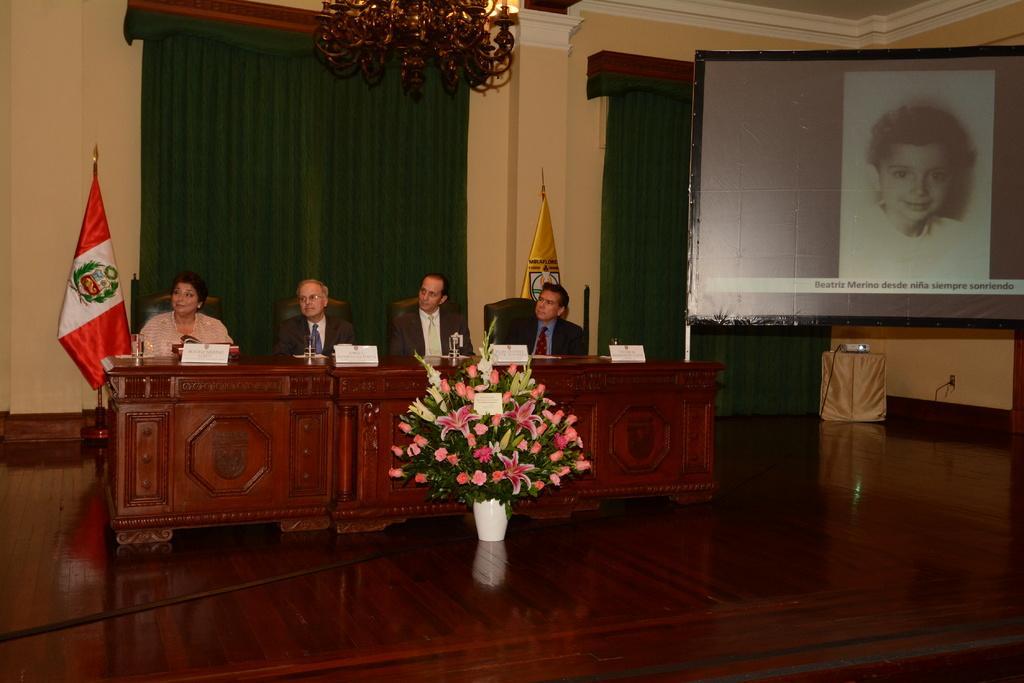Could you give a brief overview of what you see in this image? This 4 persons are sitting on chair. In-front of this 4 persons there is a table. On floor there is a bouquet with card. Beside this woman there is a flag. Curtain is in green color. Banner of a kid. On a table there is a projector. 